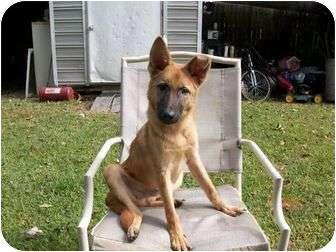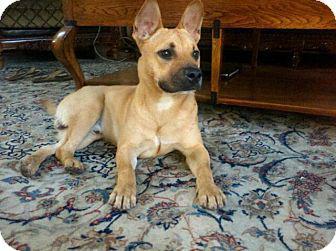The first image is the image on the left, the second image is the image on the right. Assess this claim about the two images: "An image shows a person at the left, interacting with one big dog.". Correct or not? Answer yes or no. No. The first image is the image on the left, the second image is the image on the right. For the images displayed, is the sentence "The left image contains one person standing to the left of a dog." factually correct? Answer yes or no. No. 